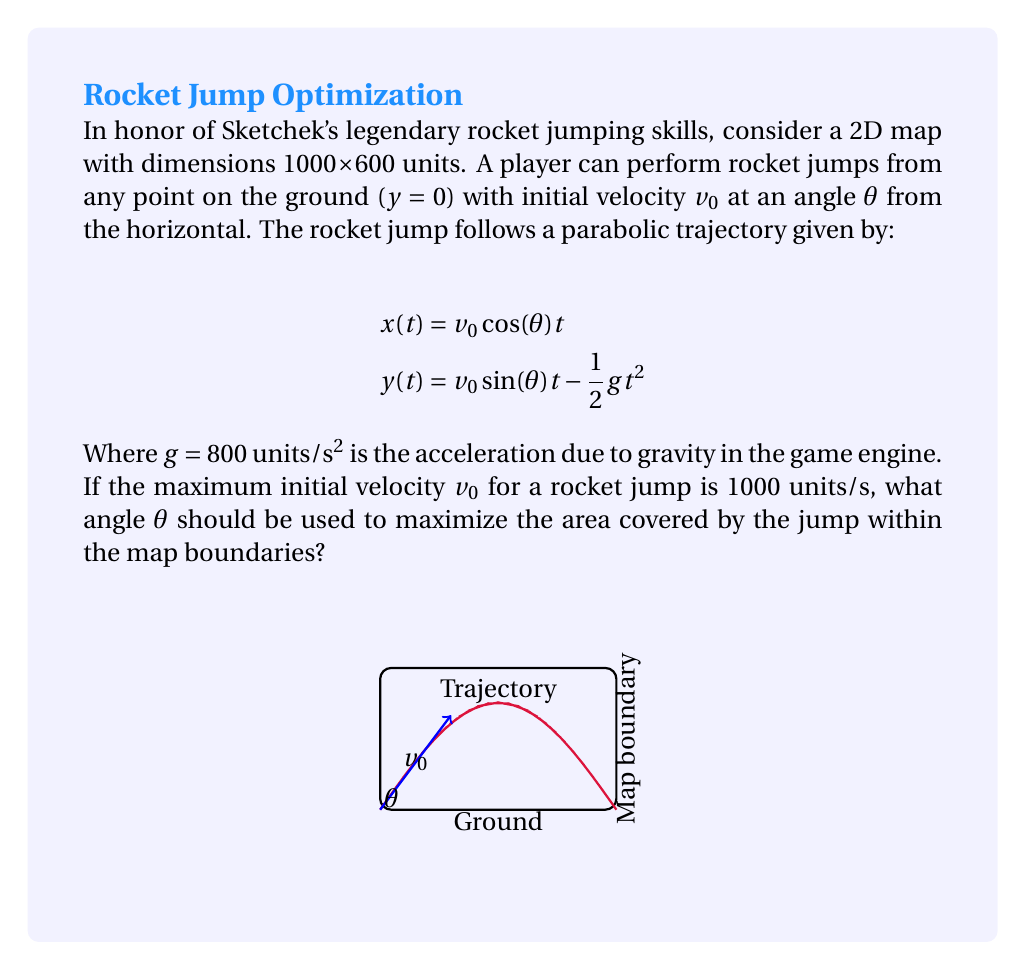Can you answer this question? Let's approach this step-by-step:

1) The area covered by the jump is maximized when the jump reaches the top corner of the map (1000, 600).

2) We need to find the angle $\theta$ that allows the projectile to reach this point.

3) The time to reach the maximum height is:

   $$t_{max} = \frac{v_0 \sin(\theta)}{g}$$

4) The total time of flight is twice this:

   $$t_{total} = \frac{2v_0 \sin(\theta)}{g}$$

5) For the projectile to reach x = 1000 at the end of its flight:

   $$1000 = v_0 \cos(\theta) \cdot \frac{2v_0 \sin(\theta)}{g}$$

6) Simplify:

   $$1000 = \frac{2v_0^2 \sin(\theta)\cos(\theta)}{g}$$

7) Use the identity $2\sin(\theta)\cos(\theta) = \sin(2\theta)$:

   $$1000 = \frac{v_0^2 \sin(2\theta)}{g}$$

8) Solve for $\sin(2\theta)$:

   $$\sin(2\theta) = \frac{1000g}{v_0^2} = \frac{1000 \cdot 800}{1000^2} = 0.8$$

9) Therefore:

   $$2\theta = \arcsin(0.8)$$
   $$\theta = \frac{1}{2}\arcsin(0.8) \approx 26.57°$$

10) Verify that this angle also results in y = 600 at the apex:

    $$y_{max} = \frac{v_0^2 \sin^2(\theta)}{2g} \approx 600.0$$

Thus, the optimal angle is approximately 26.57°.
Answer: $\theta \approx 26.57°$ 